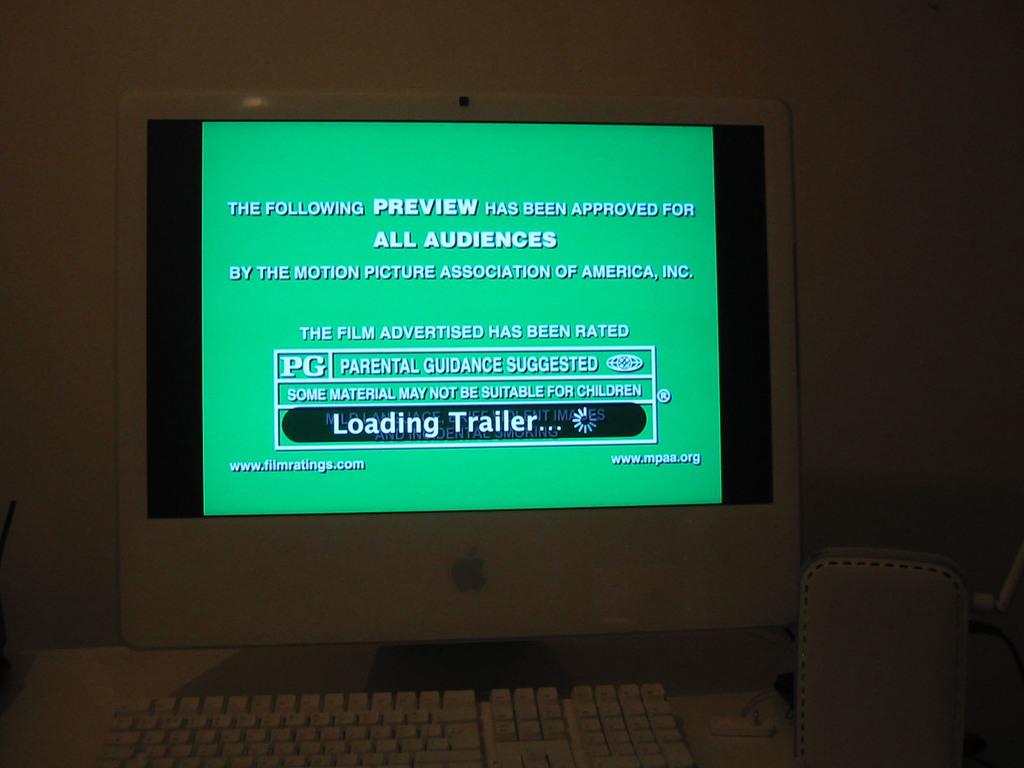Who has been approved for this trailer?
Offer a very short reply. All audiences. What is the film rated?
Offer a very short reply. Pg. 